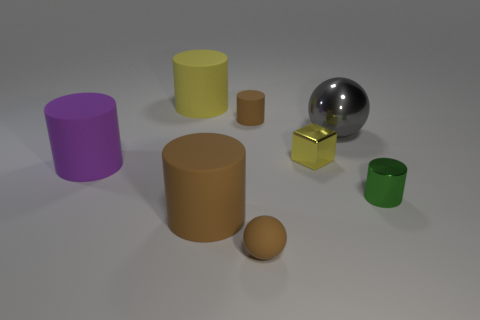Subtract all green metal cylinders. How many cylinders are left? 4 Add 1 big green rubber spheres. How many objects exist? 9 Subtract all green cylinders. How many cylinders are left? 4 Subtract 4 cylinders. How many cylinders are left? 1 Subtract all spheres. How many objects are left? 6 Add 2 small green metal cylinders. How many small green metal cylinders are left? 3 Add 4 metal spheres. How many metal spheres exist? 5 Subtract 0 gray cubes. How many objects are left? 8 Subtract all cyan cylinders. Subtract all green spheres. How many cylinders are left? 5 Subtract all blue cylinders. How many purple spheres are left? 0 